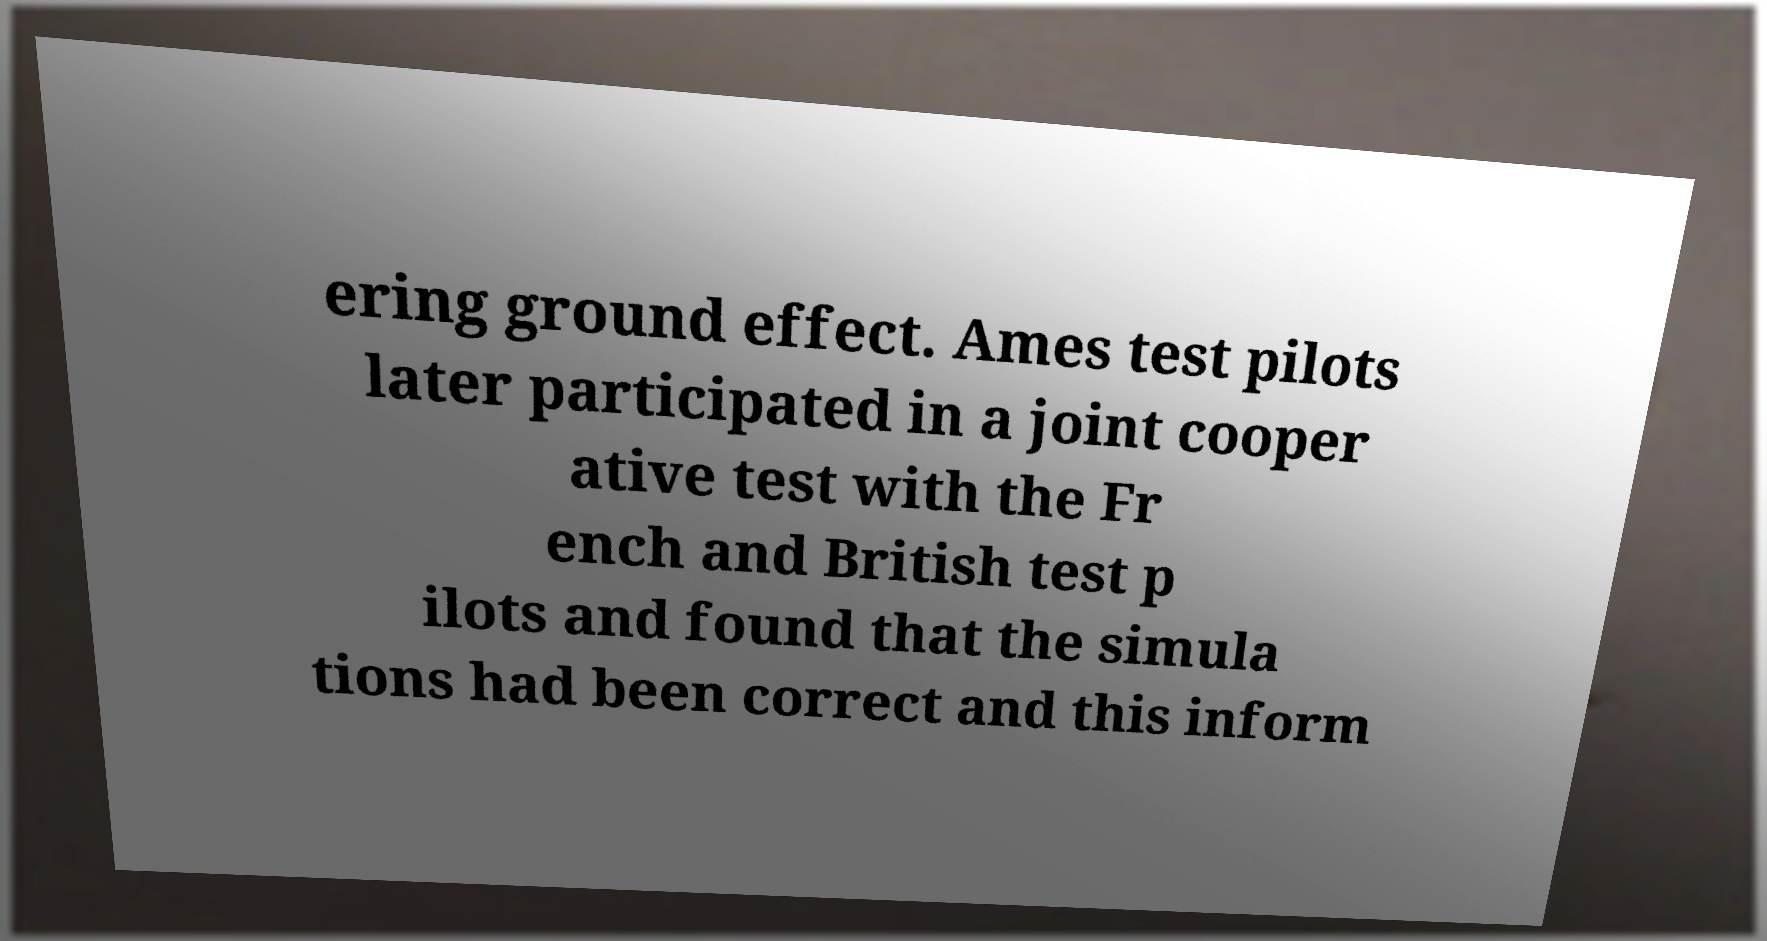Please read and relay the text visible in this image. What does it say? ering ground effect. Ames test pilots later participated in a joint cooper ative test with the Fr ench and British test p ilots and found that the simula tions had been correct and this inform 